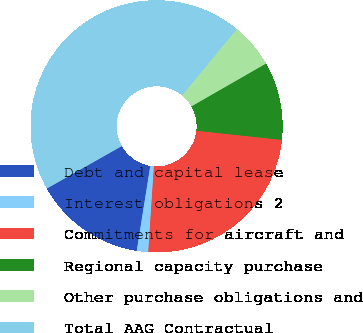Convert chart. <chart><loc_0><loc_0><loc_500><loc_500><pie_chart><fcel>Debt and capital lease<fcel>Interest obligations 2<fcel>Commitments for aircraft and<fcel>Regional capacity purchase<fcel>Other purchase obligations and<fcel>Total AAG Contractual<nl><fcel>14.28%<fcel>1.47%<fcel>24.33%<fcel>10.01%<fcel>5.74%<fcel>44.17%<nl></chart> 